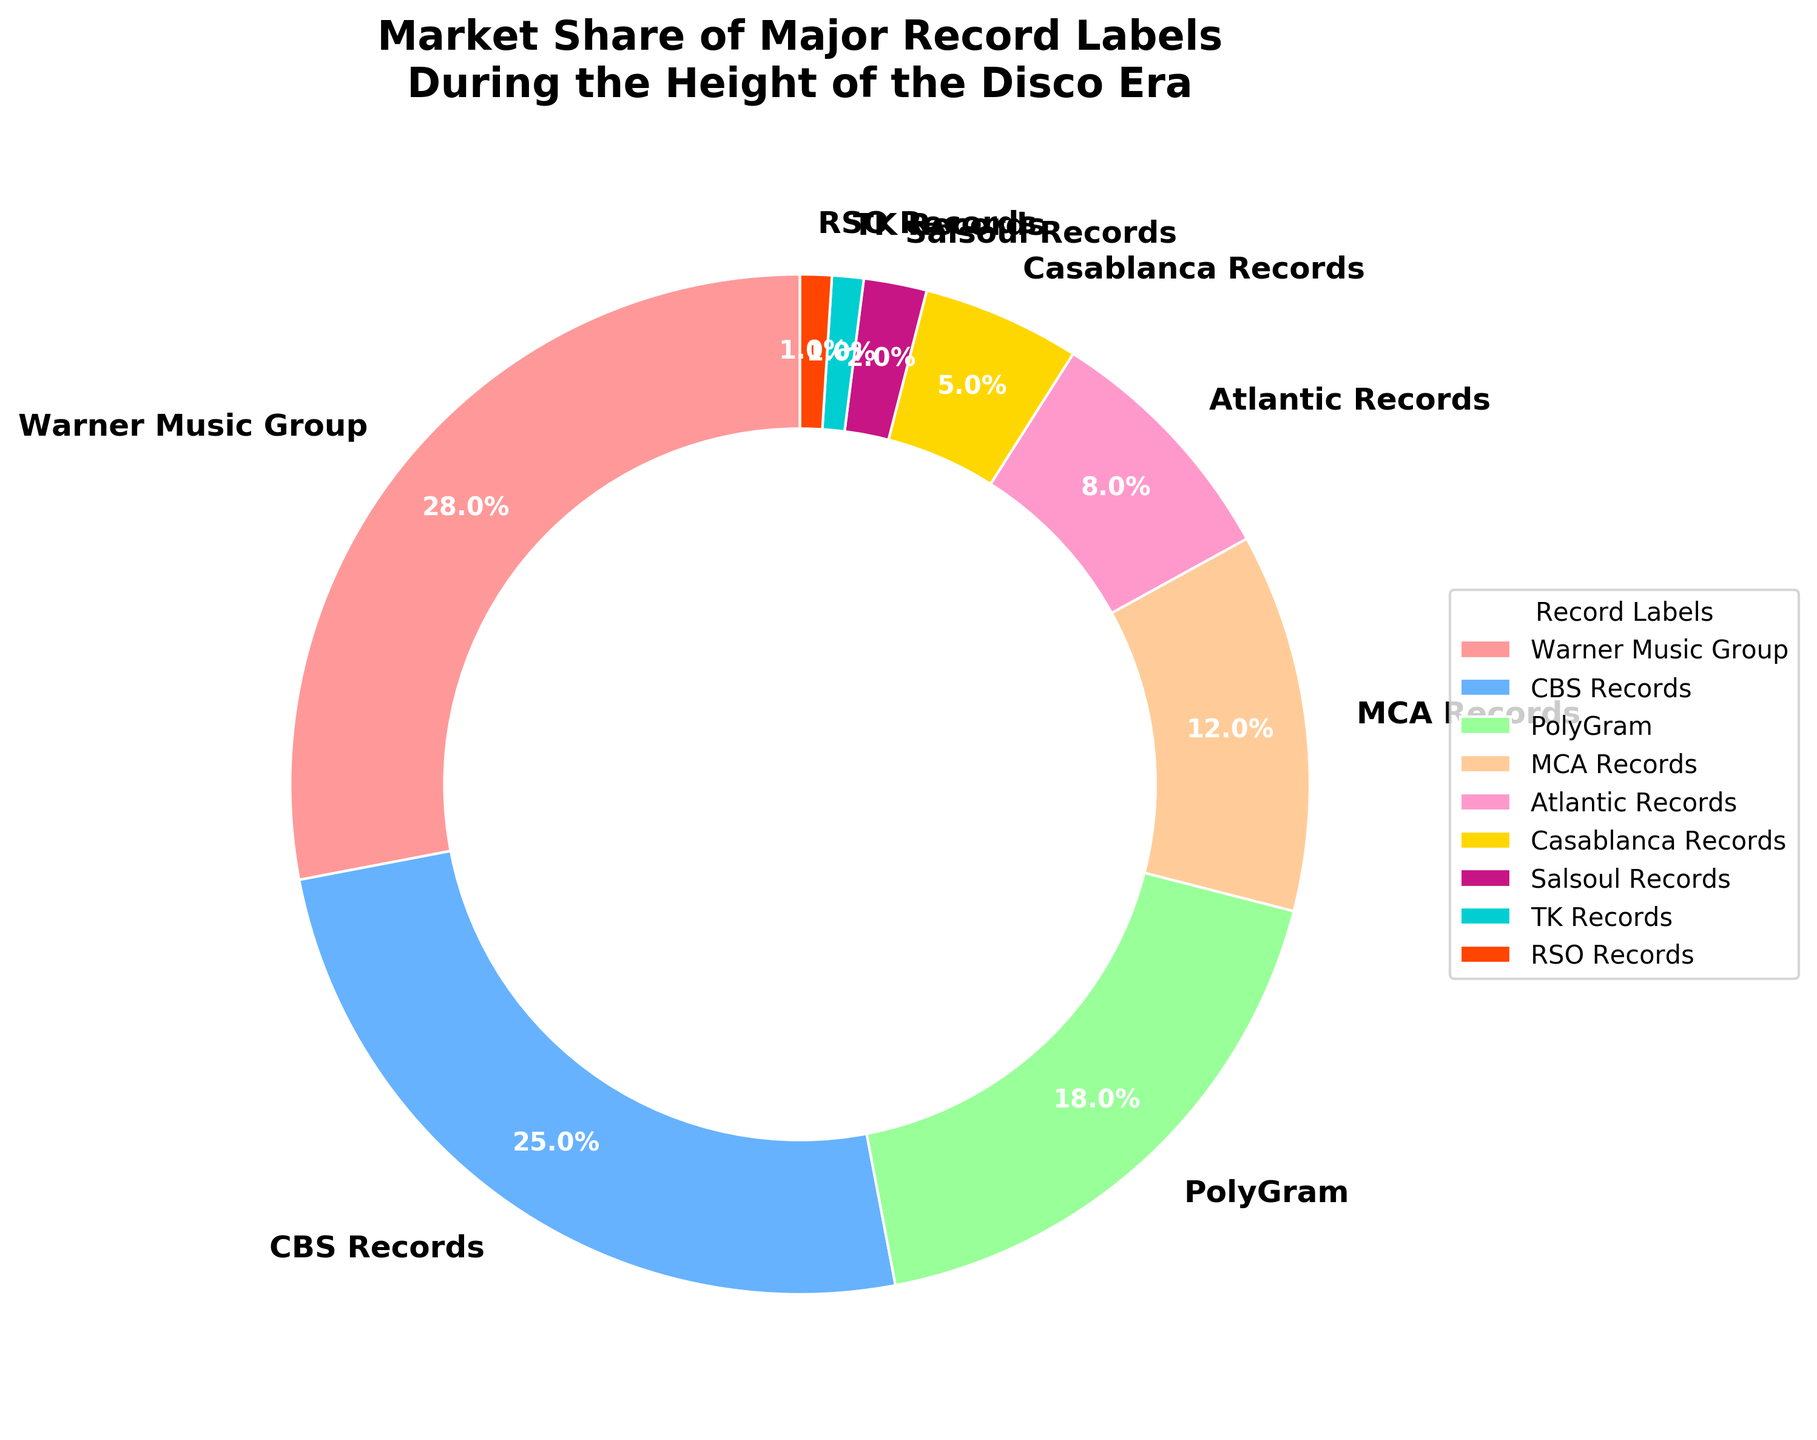What's the largest market share percentage? By looking at the pie chart, the largest segment corresponds to Warner Music Group, which is labeled as having the highest percentage. The percentage is displayed as 28%.
Answer: 28% Which record label has the second largest market share? The second largest segment in the pie chart is CBS Records, with the label indicating a 25% market share.
Answer: CBS Records What is the combined market share of MCA Records and Atlantic Records? The market share of MCA Records is 12% and Atlantic Records is 8%. Adding these two values together: 12% + 8% = 20%.
Answer: 20% Is PolyGram's market share greater than MCA Records'? PolyGram has an 18% market share, and MCA Records has a 12% market share. Since 18% is greater than 12%, PolyGram has a larger market share.
Answer: Yes Which record labels have a combined market share of less than 10%? Casablanca Records has 5%, Salsoul Records has 2%, TK Records has 1%, and RSO Records has 1%. Adding these together: 5% + 2% + 1% + 1% = 9%. These labels have a combined market share of less than 10%.
Answer: Casablanca Records, Salsoul Records, TK Records, RSO Records What is the difference between the market share of the largest and smallest record labels? The largest market share is 28% (Warner Music Group) and the smallest is 1% (TK Records and RSO Records). The difference is 28% - 1% = 27%.
Answer: 27% What color represents CBS Records in the chart? Examining the pie chart, CBS Records section is displayed as the second largest segment, colored in blue.
Answer: Blue How many record labels have a market share of more than 10%? Warner Music Group (28%), CBS Records (25%), PolyGram (18%), and MCA Records (12%) all have market shares greater than 10%. There are 4 such record labels.
Answer: 4 Which record labels share an orange color in the pie chart? By checking the pie chart, only one segment is colored orange, which corresponds to RSO Records.
Answer: RSO Records 